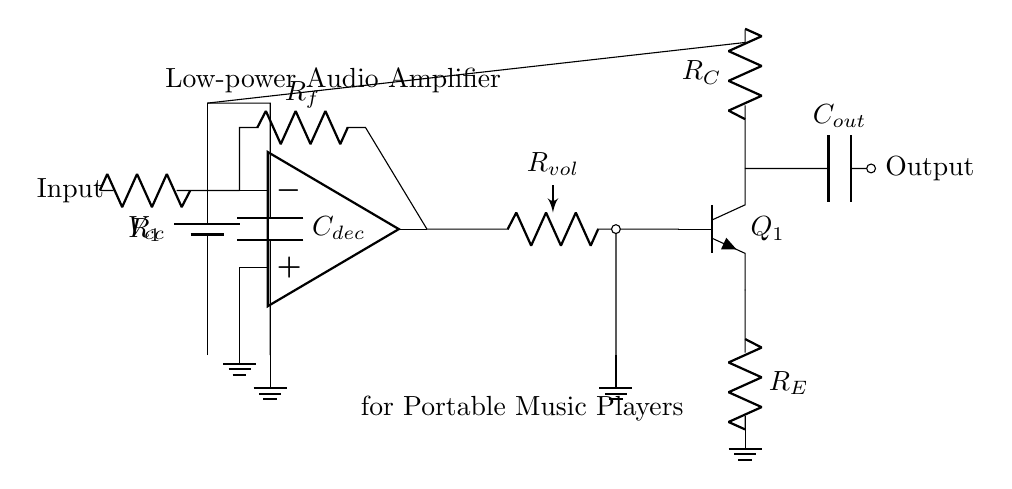what type of amplifier is shown in the circuit? The circuit depicts a low-power audio amplifier suitable for portable music players, which is specifically designed to amplify audio signals with minimal power consumption.
Answer: low-power audio amplifier what are the values of the resistors in the input stage? The circuit uses two resistors labeled as R1 and Rf. The specific numerical values are not indicated in the diagram; however, they are critical for setting gain and input impedance.
Answer: R1 and Rf what is the purpose of the volume control in the circuit? The volume control, represented by Rvol, adjusts the amplitude of the output signal by changing the resistance, thus allowing the user to modify the loudness of the audio signal.
Answer: adjust volume which component is used for output coupling? The output coupling is achieved using a capacitor labeled as Cout, which blocks DC voltage while allowing AC audio signals to pass to the output, maintaining the audio quality.
Answer: Cout how does the output stage amplify the audio signal? The amplifier stage employs a transistor labeled Q1, which acts as a current amplifier. The transistor's base is fed with the amplified input from the operational amplifier, resulting in increased output current while maintaining the audio waveform.
Answer: through Q1 what is the effect of the decoupling capacitor in this circuit? The decoupling capacitor, labeled Cdec, filters out noise from the power supply, ensuring stable voltage levels and preventing fluctuations that could degrade audio quality in the amplifier circuit.
Answer: stabilize voltage what is the grounding configuration in the circuit? The circuit features multiple grounding points, notably connected to the negative side of the battery and the emitter of the transistor, establishing a reference point for the signal path and allowing proper operation of the amplifier.
Answer: multiple grounds 